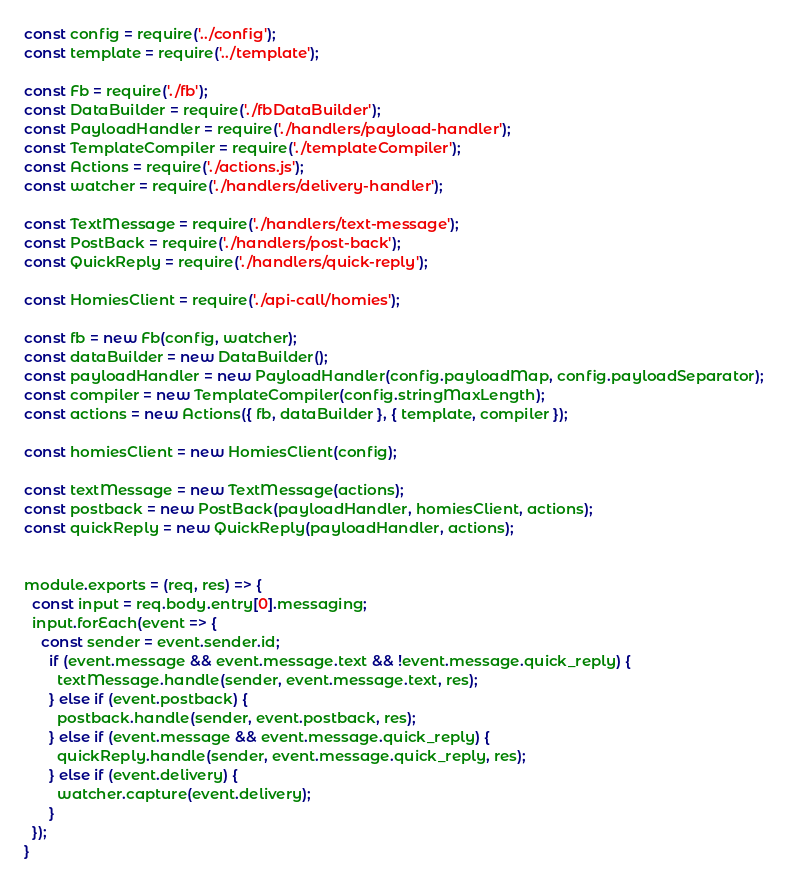<code> <loc_0><loc_0><loc_500><loc_500><_JavaScript_>const config = require('../config');
const template = require('../template');

const Fb = require('./fb');
const DataBuilder = require('./fbDataBuilder');
const PayloadHandler = require('./handlers/payload-handler');
const TemplateCompiler = require('./templateCompiler');
const Actions = require('./actions.js');
const watcher = require('./handlers/delivery-handler');

const TextMessage = require('./handlers/text-message');
const PostBack = require('./handlers/post-back');
const QuickReply = require('./handlers/quick-reply');

const HomiesClient = require('./api-call/homies');

const fb = new Fb(config, watcher);
const dataBuilder = new DataBuilder();
const payloadHandler = new PayloadHandler(config.payloadMap, config.payloadSeparator);
const compiler = new TemplateCompiler(config.stringMaxLength);
const actions = new Actions({ fb, dataBuilder }, { template, compiler });

const homiesClient = new HomiesClient(config);

const textMessage = new TextMessage(actions);
const postback = new PostBack(payloadHandler, homiesClient, actions);
const quickReply = new QuickReply(payloadHandler, actions);


module.exports = (req, res) => {
  const input = req.body.entry[0].messaging;
  input.forEach(event => {
    const sender = event.sender.id;
      if (event.message && event.message.text && !event.message.quick_reply) {        
        textMessage.handle(sender, event.message.text, res); 
      } else if (event.postback) {
        postback.handle(sender, event.postback, res);
      } else if (event.message && event.message.quick_reply) {
        quickReply.handle(sender, event.message.quick_reply, res);
      } else if (event.delivery) {
        watcher.capture(event.delivery);
      }   
  });
}
</code> 